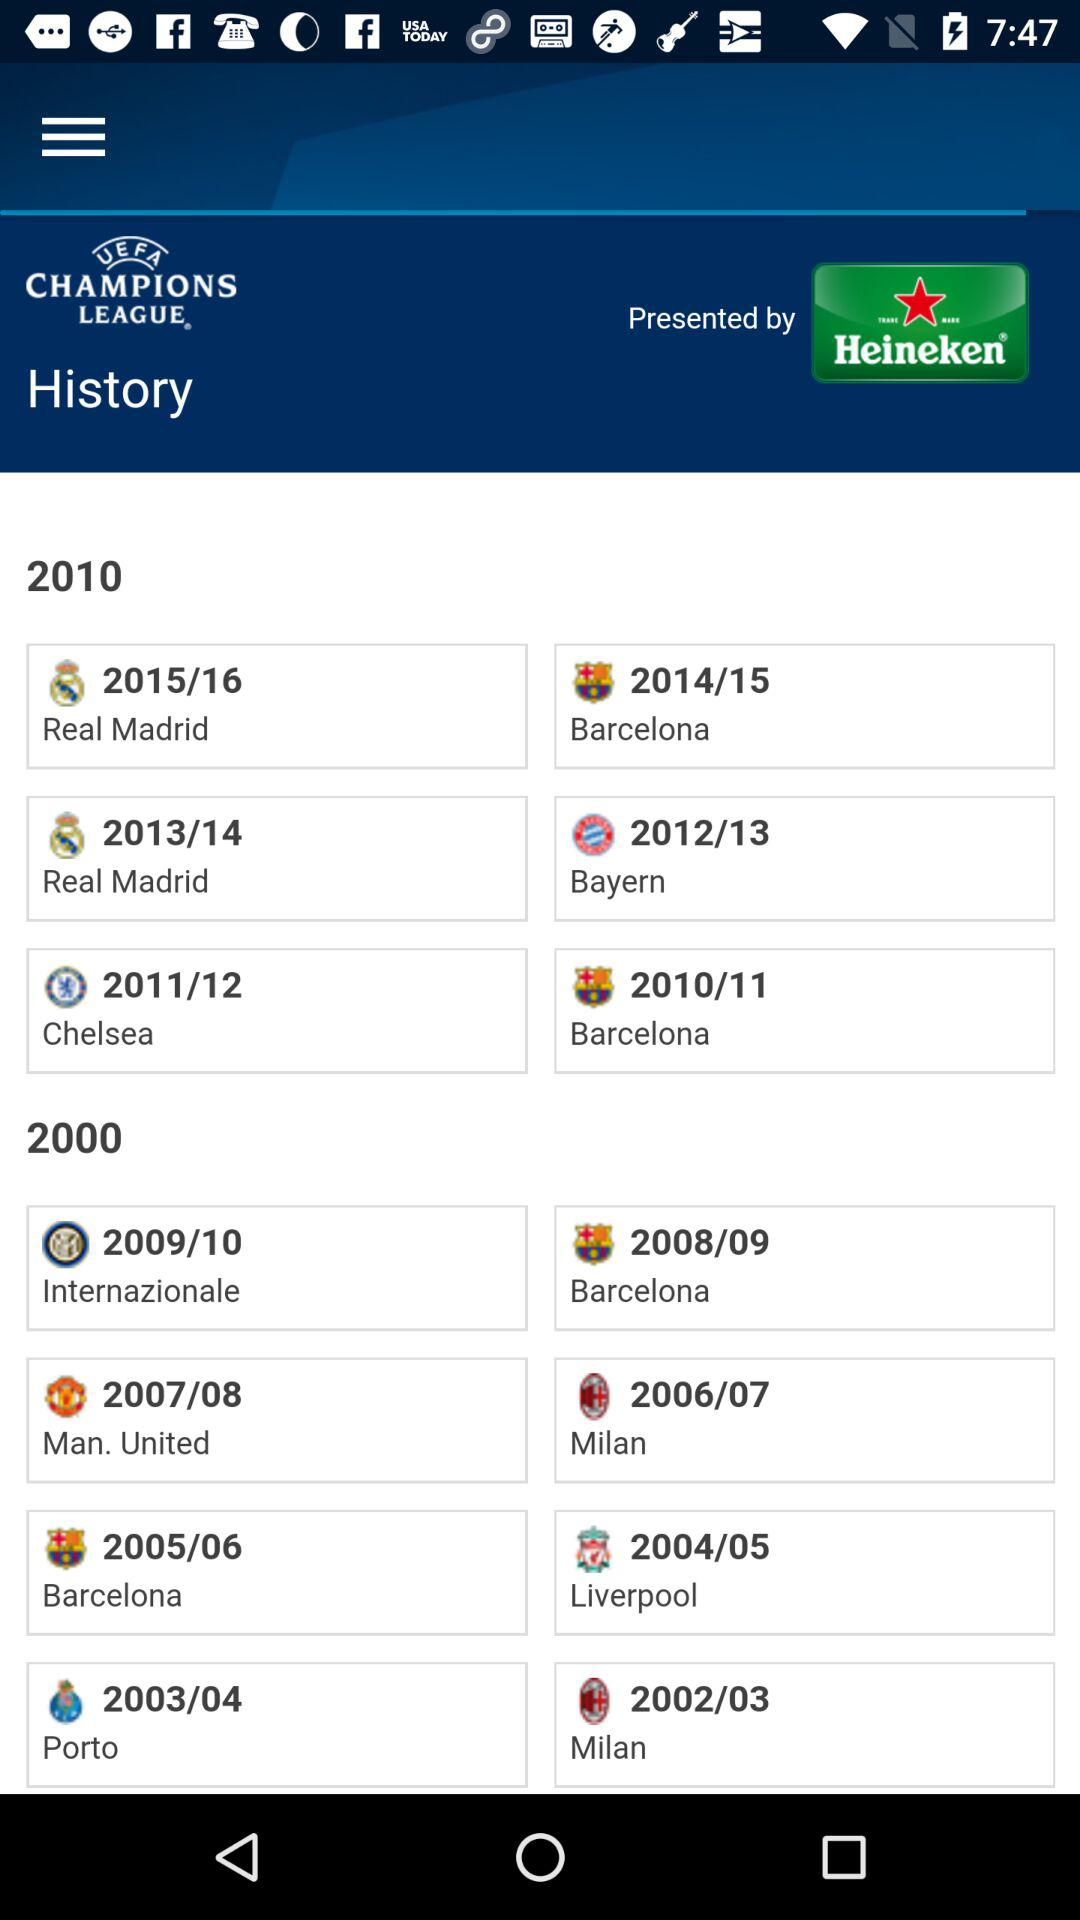What is the application name? The application name is "UEFA Champions League". 